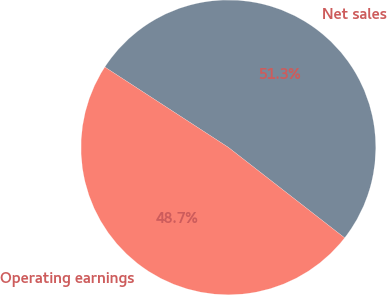Convert chart to OTSL. <chart><loc_0><loc_0><loc_500><loc_500><pie_chart><fcel>Net sales<fcel>Operating earnings<nl><fcel>51.35%<fcel>48.65%<nl></chart> 